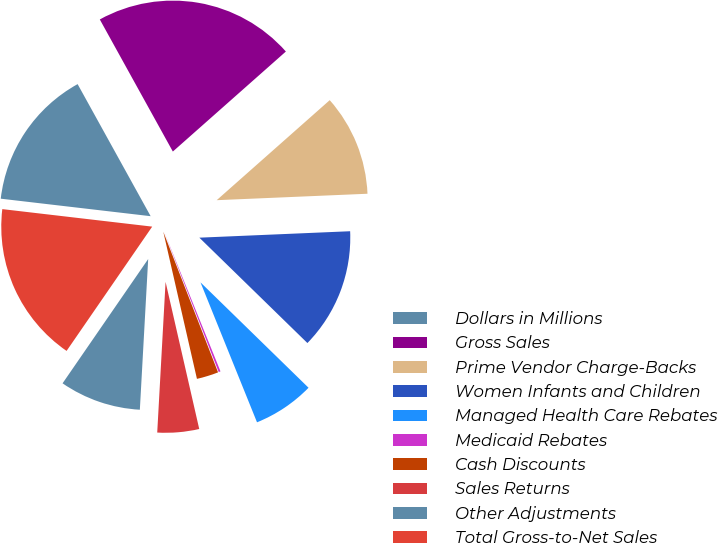Convert chart. <chart><loc_0><loc_0><loc_500><loc_500><pie_chart><fcel>Dollars in Millions<fcel>Gross Sales<fcel>Prime Vendor Charge-Backs<fcel>Women Infants and Children<fcel>Managed Health Care Rebates<fcel>Medicaid Rebates<fcel>Cash Discounts<fcel>Sales Returns<fcel>Other Adjustments<fcel>Total Gross-to-Net Sales<nl><fcel>15.11%<fcel>21.51%<fcel>10.85%<fcel>12.98%<fcel>6.59%<fcel>0.2%<fcel>2.33%<fcel>4.46%<fcel>8.72%<fcel>17.25%<nl></chart> 